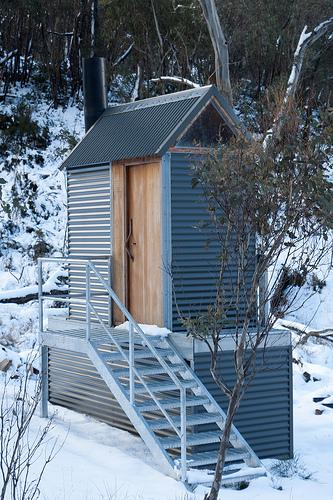What is the primary color of the house, and where can you find a window on it? The primary color of the house is blue, and there is a window on the roof of the building. Can you describe the features of the stairs in the image? The stairs in the image are grey, made of cold metal steps, and they have cold metal handrails. What kind of product advertisement could be developed based on this image? An advertisement for resilient outdoor paint or insulation could be developed, focusing on the snow cabin's ability to withstand harsh winter conditions. List any objects in the image that are related to the weather. There are several objects related to the weather, such as white snow on the ground and stairs, and bare trees in the background. Briefly describe the building and its characteristics. The building is a small, primarily blue snow cabin, possibly a tiny house, with snow on a black roof, and it has no windows. Can you describe the chimney and any other features on the roof of the building? The chimney is black, possibly made from metal, and is located on the grey-colored roof. There is no window on the roof. Describe the appearance of the ground and its surroundings. The ground appears white due to the snow, with some brown bare bushes and a log on the snowy ground. Grass can also be seen peeking through the snow. Identify an interesting feature about the door and its handle. The door handle is unusually curved or warped, and the door itself may have a glass section. 